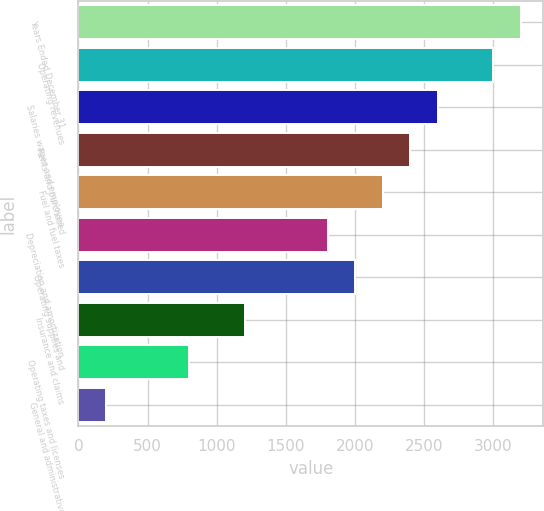Convert chart to OTSL. <chart><loc_0><loc_0><loc_500><loc_500><bar_chart><fcel>Years Ended December 31<fcel>Operating revenues<fcel>Salaries wages and employee<fcel>Rents and purchased<fcel>Fuel and fuel taxes<fcel>Depreciation and amortization<fcel>Operating supplies and<fcel>Insurance and claims<fcel>Operating taxes and licenses<fcel>General and administrative<nl><fcel>3201.3<fcel>3001.25<fcel>2601.15<fcel>2401.1<fcel>2201.05<fcel>1800.95<fcel>2001<fcel>1200.8<fcel>800.7<fcel>200.55<nl></chart> 